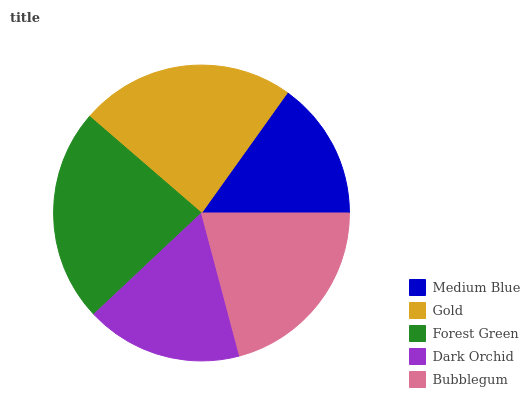Is Medium Blue the minimum?
Answer yes or no. Yes. Is Gold the maximum?
Answer yes or no. Yes. Is Forest Green the minimum?
Answer yes or no. No. Is Forest Green the maximum?
Answer yes or no. No. Is Gold greater than Forest Green?
Answer yes or no. Yes. Is Forest Green less than Gold?
Answer yes or no. Yes. Is Forest Green greater than Gold?
Answer yes or no. No. Is Gold less than Forest Green?
Answer yes or no. No. Is Bubblegum the high median?
Answer yes or no. Yes. Is Bubblegum the low median?
Answer yes or no. Yes. Is Medium Blue the high median?
Answer yes or no. No. Is Forest Green the low median?
Answer yes or no. No. 